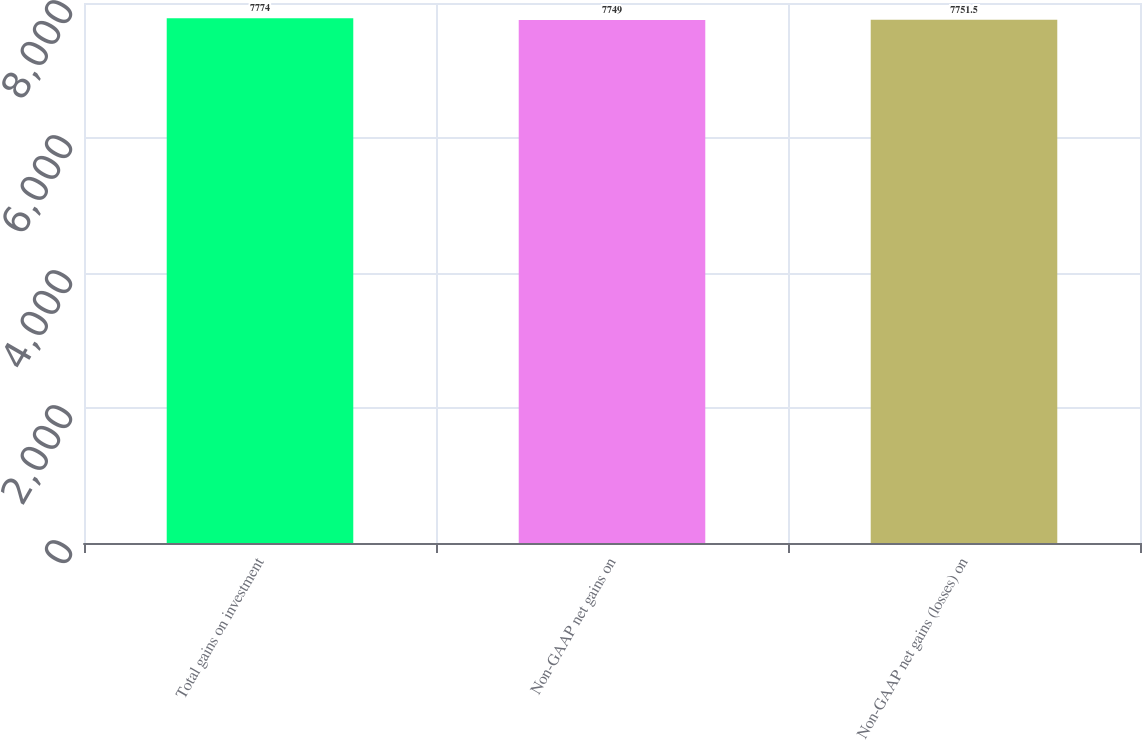Convert chart to OTSL. <chart><loc_0><loc_0><loc_500><loc_500><bar_chart><fcel>Total gains on investment<fcel>Non-GAAP net gains on<fcel>Non-GAAP net gains (losses) on<nl><fcel>7774<fcel>7749<fcel>7751.5<nl></chart> 